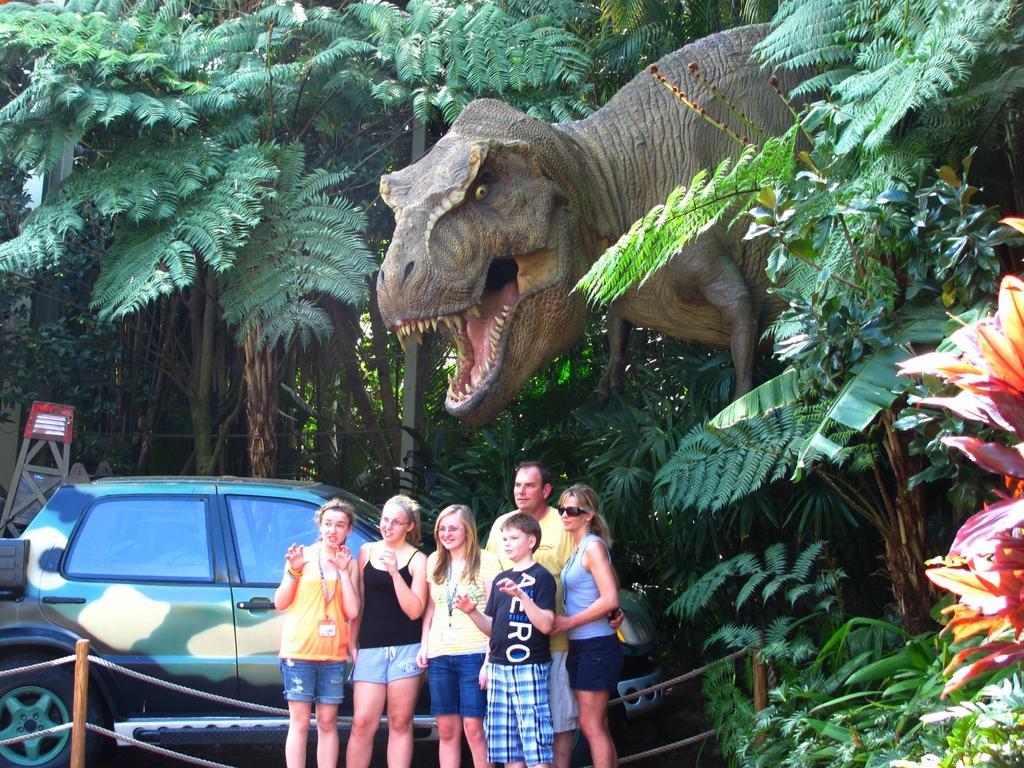Describe this image in one or two sentences. In this picture we can see a car and a group of people standing on the ground and smiling and in the background we can see a dinosaur and trees. 